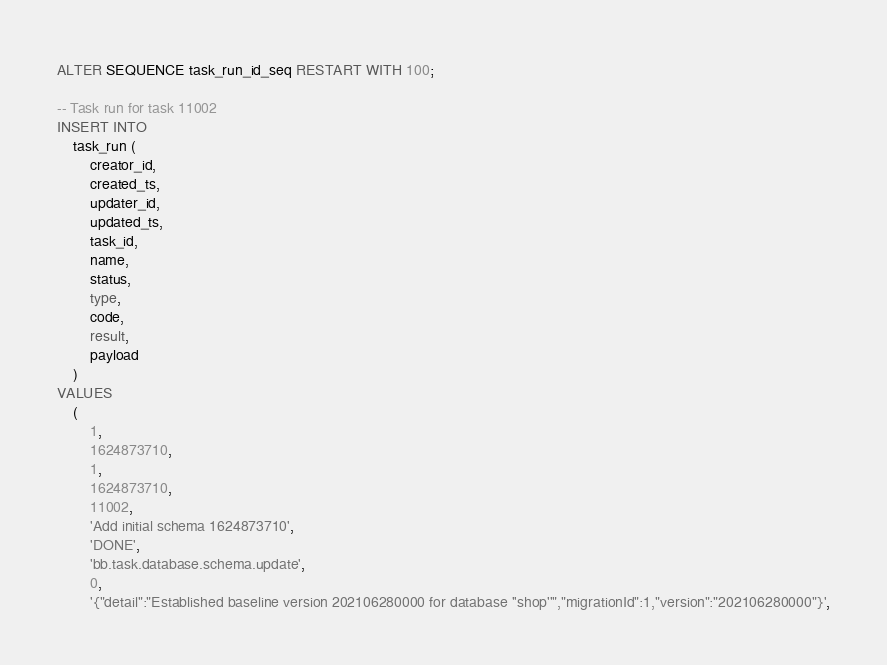<code> <loc_0><loc_0><loc_500><loc_500><_SQL_>ALTER SEQUENCE task_run_id_seq RESTART WITH 100;

-- Task run for task 11002
INSERT INTO
    task_run (
        creator_id,
        created_ts,
        updater_id,
        updated_ts,
        task_id,
        name,
        status,
        type,
        code,
        result,
        payload
    )
VALUES
    (
        1,
        1624873710,
        1,
        1624873710,
        11002,
        'Add initial schema 1624873710',
        'DONE',
        'bb.task.database.schema.update',
        0,
        '{"detail":"Established baseline version 202106280000 for database ''shop''","migrationId":1,"version":"202106280000"}',</code> 